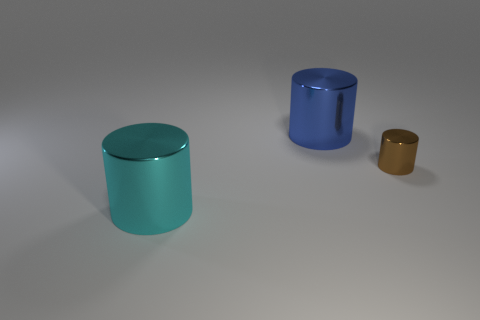Add 2 cyan metal objects. How many objects exist? 5 Subtract 0 brown balls. How many objects are left? 3 Subtract all large red matte blocks. Subtract all blue metallic things. How many objects are left? 2 Add 2 tiny metallic objects. How many tiny metallic objects are left? 3 Add 2 purple rubber spheres. How many purple rubber spheres exist? 2 